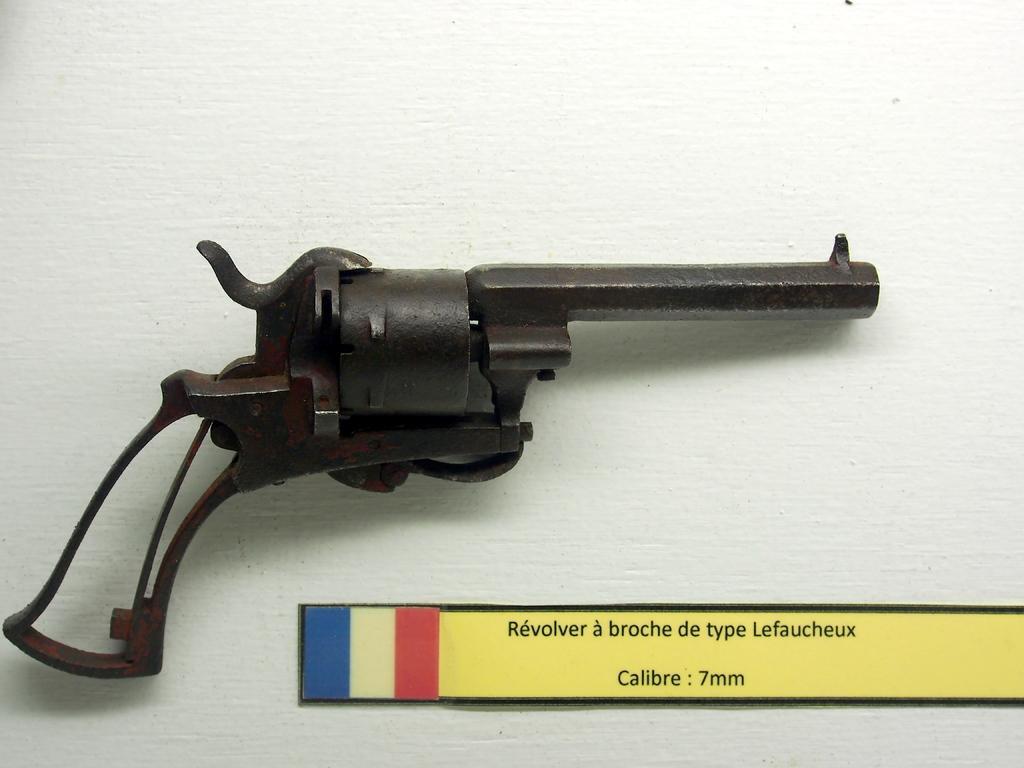In one or two sentences, can you explain what this image depicts? In this picture I can see a gun and a board on an object. 